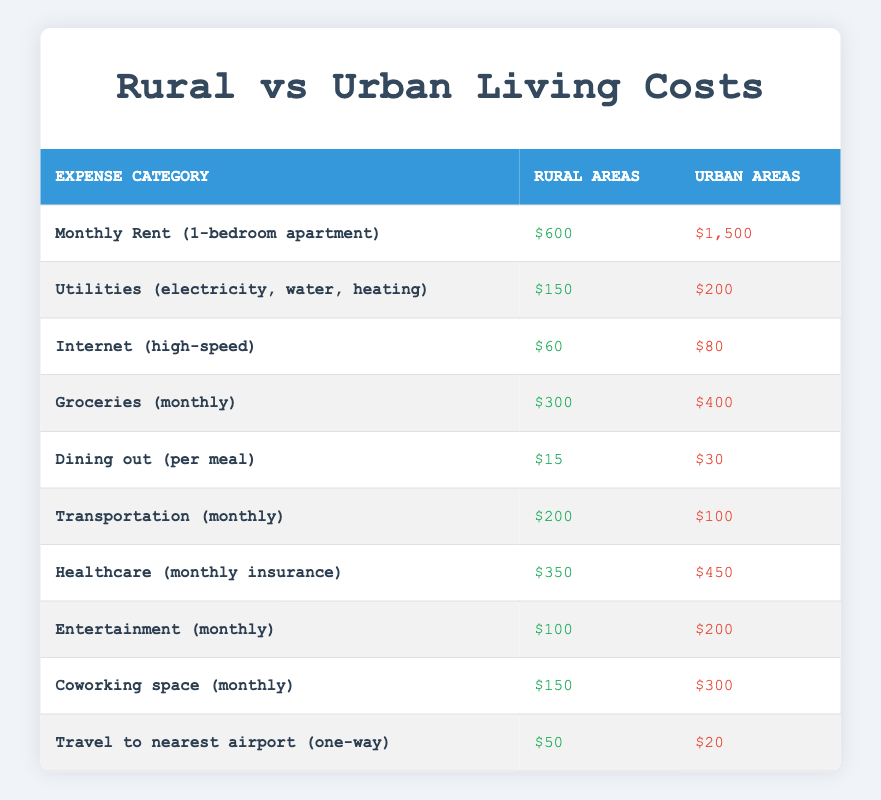What is the cost of monthly rent for a 1-bedroom apartment in rural areas? The table shows that the monthly rent for a 1-bedroom apartment in rural areas is listed as $600.
Answer: $600 What is the cost of groceries in urban areas compared to rural areas? In urban areas, the cost of groceries is $400 while in rural areas it is $300. The difference is $400 - $300 = $100.
Answer: $100 Is dining out more expensive in urban areas than in rural areas? The cost of dining out in urban areas is $30, which is more than the $15 cost in rural areas. Therefore, it is true that dining out is more expensive in urban areas.
Answer: Yes What is the total cost of utilities in rural areas compared to urban areas? In rural areas, utilities cost $150, and in urban areas, they cost $200. The total cost in urban areas is higher by $200 - $150 = $50.
Answer: $50 What is the average cost of healthcare and entertainment in urban areas? The cost of healthcare in urban areas is $450, and entertainment is $200. To find the average, sum these costs: $450 + $200 = $650, and divide by 2: $650 / 2 = $325.
Answer: $325 What is the total amount spent on coworking space and internet in rural areas? The table shows that coworking space in rural areas costs $150 and the internet costs $60. The total expenditure for both is $150 + $60 = $210.
Answer: $210 Is transportation cheaper in urban areas than in rural areas? The cost of transportation in urban areas is $100, while in rural areas it is $200. This means transportation is less expensive in urban areas.
Answer: Yes By how much does the monthly rent in urban areas exceed that in rural areas? The monthly rent in urban areas is $1,500 and in rural areas it is $600. The difference is $1,500 - $600 = $900, indicating that urban rent exceeds rural rent by $900.
Answer: $900 What is the total transportation and travel cost to the nearest airport in rural areas compared to urban areas? In rural areas, transportation costs $200 and travel to the nearest airport is $50, totaling $200 + $50 = $250. In urban areas, transportation is $100, and travel to the nearest airport is $20, totaling $100 + $20 = $120. Therefore, rural areas have $250 - $120 = $130 more total travel and transportation costs than urban areas.
Answer: $130 